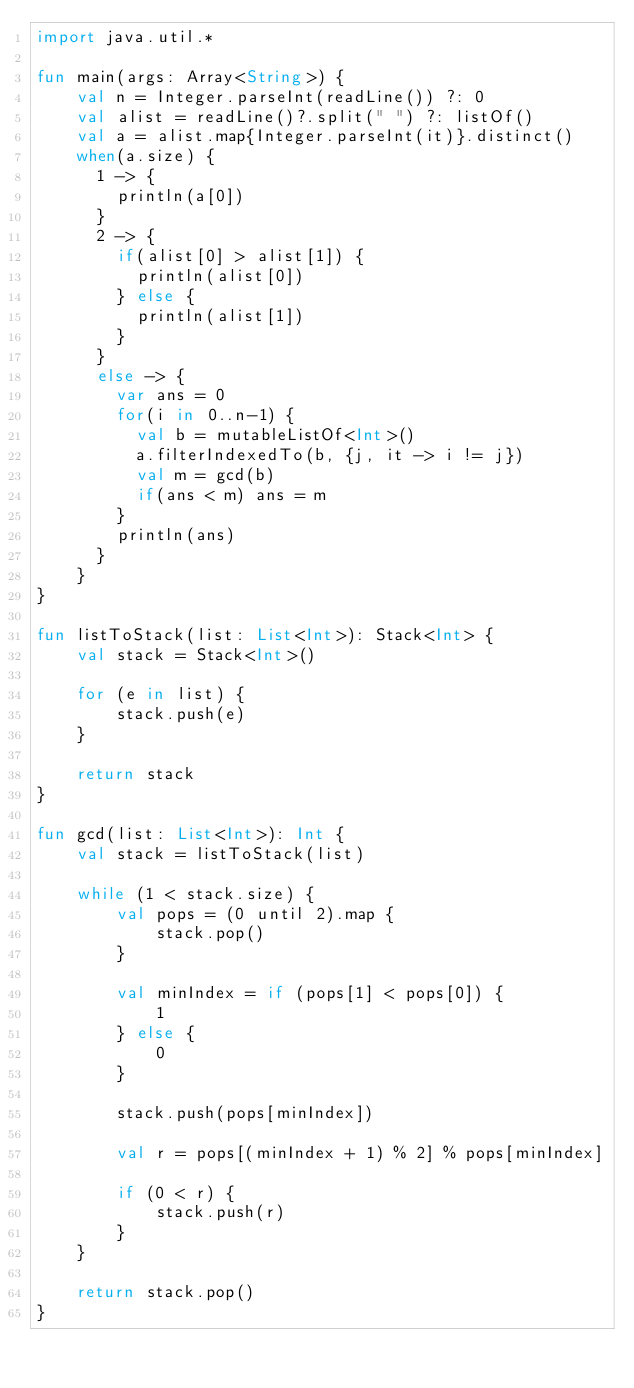<code> <loc_0><loc_0><loc_500><loc_500><_Kotlin_>import java.util.*

fun main(args: Array<String>) {
    val n = Integer.parseInt(readLine()) ?: 0
    val alist = readLine()?.split(" ") ?: listOf()
    val a = alist.map{Integer.parseInt(it)}.distinct()
    when(a.size) {
      1 -> {
        println(a[0])
      }
      2 -> {
        if(alist[0] > alist[1]) {
          println(alist[0])
        } else {
          println(alist[1])
        }
      }
      else -> {
        var ans = 0
        for(i in 0..n-1) {
          val b = mutableListOf<Int>()
          a.filterIndexedTo(b, {j, it -> i != j})
          val m = gcd(b)
          if(ans < m) ans = m
        }
        println(ans)
      }
    }
}

fun listToStack(list: List<Int>): Stack<Int> {
    val stack = Stack<Int>()

    for (e in list) {
        stack.push(e)
    }

    return stack
}

fun gcd(list: List<Int>): Int {
    val stack = listToStack(list)

    while (1 < stack.size) {
        val pops = (0 until 2).map {
            stack.pop()
        }

        val minIndex = if (pops[1] < pops[0]) {
            1
        } else {
            0
        }

        stack.push(pops[minIndex])

        val r = pops[(minIndex + 1) % 2] % pops[minIndex]

        if (0 < r) {
            stack.push(r)
        }
    }

    return stack.pop()
}</code> 